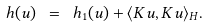<formula> <loc_0><loc_0><loc_500><loc_500>h ( u ) \ = \ h _ { 1 } ( u ) + \langle K u , K u \rangle _ { H } .</formula> 